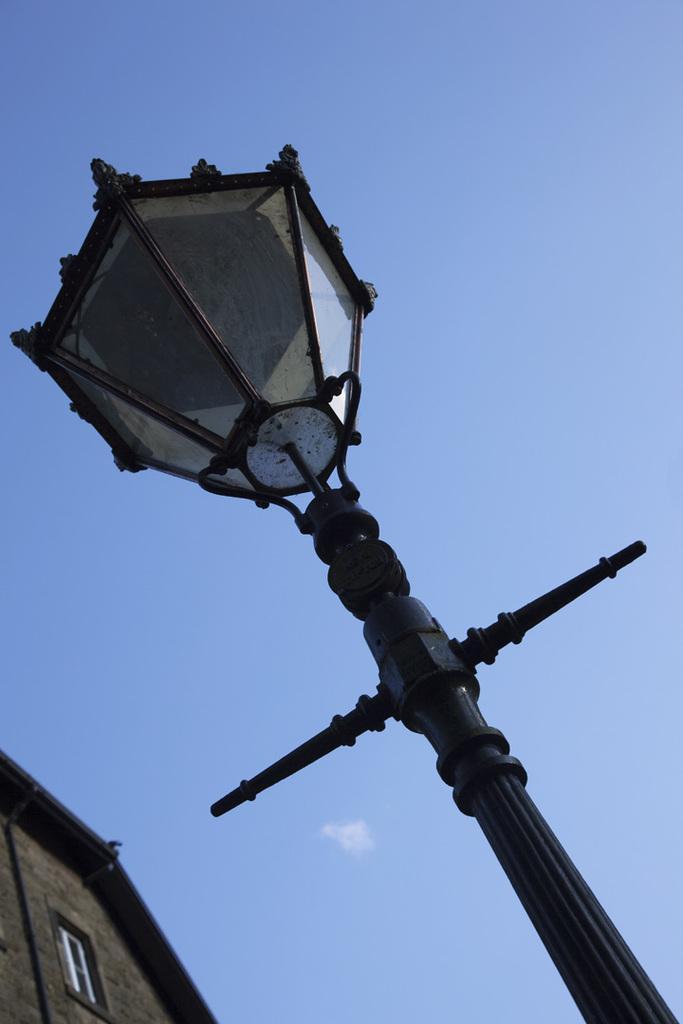Can you describe this image briefly? In this image I can see the light pole. To the left I can see the building. In the background I can see the sky. 